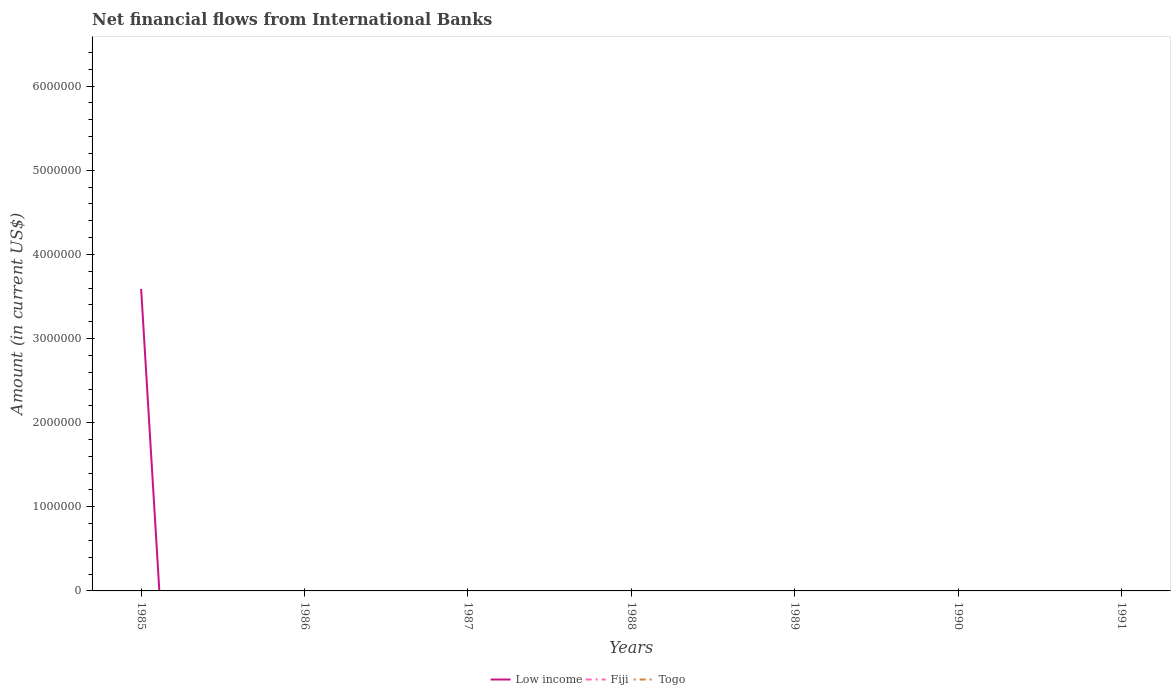How many different coloured lines are there?
Your answer should be compact. 1. Is the number of lines equal to the number of legend labels?
Provide a succinct answer. No. Across all years, what is the maximum net financial aid flows in Togo?
Provide a succinct answer. 0. What is the difference between the highest and the second highest net financial aid flows in Low income?
Ensure brevity in your answer.  3.59e+06. How many years are there in the graph?
Offer a terse response. 7. What is the difference between two consecutive major ticks on the Y-axis?
Your response must be concise. 1.00e+06. Does the graph contain grids?
Keep it short and to the point. No. Where does the legend appear in the graph?
Your answer should be very brief. Bottom center. What is the title of the graph?
Give a very brief answer. Net financial flows from International Banks. What is the label or title of the X-axis?
Provide a short and direct response. Years. What is the label or title of the Y-axis?
Provide a succinct answer. Amount (in current US$). What is the Amount (in current US$) of Low income in 1985?
Your response must be concise. 3.59e+06. What is the Amount (in current US$) of Fiji in 1985?
Provide a succinct answer. 0. What is the Amount (in current US$) of Fiji in 1986?
Ensure brevity in your answer.  0. What is the Amount (in current US$) of Togo in 1986?
Offer a terse response. 0. What is the Amount (in current US$) in Fiji in 1989?
Provide a succinct answer. 0. What is the Amount (in current US$) in Togo in 1990?
Provide a succinct answer. 0. What is the Amount (in current US$) in Togo in 1991?
Give a very brief answer. 0. Across all years, what is the maximum Amount (in current US$) in Low income?
Ensure brevity in your answer.  3.59e+06. Across all years, what is the minimum Amount (in current US$) of Low income?
Keep it short and to the point. 0. What is the total Amount (in current US$) in Low income in the graph?
Provide a short and direct response. 3.59e+06. What is the total Amount (in current US$) of Togo in the graph?
Your answer should be very brief. 0. What is the average Amount (in current US$) in Low income per year?
Keep it short and to the point. 5.13e+05. What is the average Amount (in current US$) in Togo per year?
Offer a very short reply. 0. What is the difference between the highest and the lowest Amount (in current US$) in Low income?
Ensure brevity in your answer.  3.59e+06. 